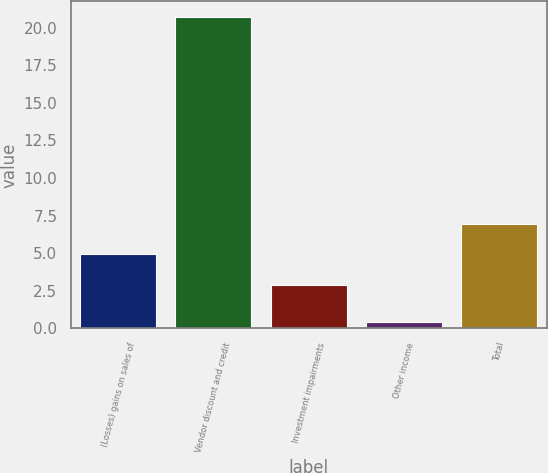<chart> <loc_0><loc_0><loc_500><loc_500><bar_chart><fcel>(Losses) gains on sales of<fcel>Vendor discount and credit<fcel>Investment impairments<fcel>Other income<fcel>Total<nl><fcel>4.93<fcel>20.7<fcel>2.9<fcel>0.4<fcel>6.96<nl></chart> 